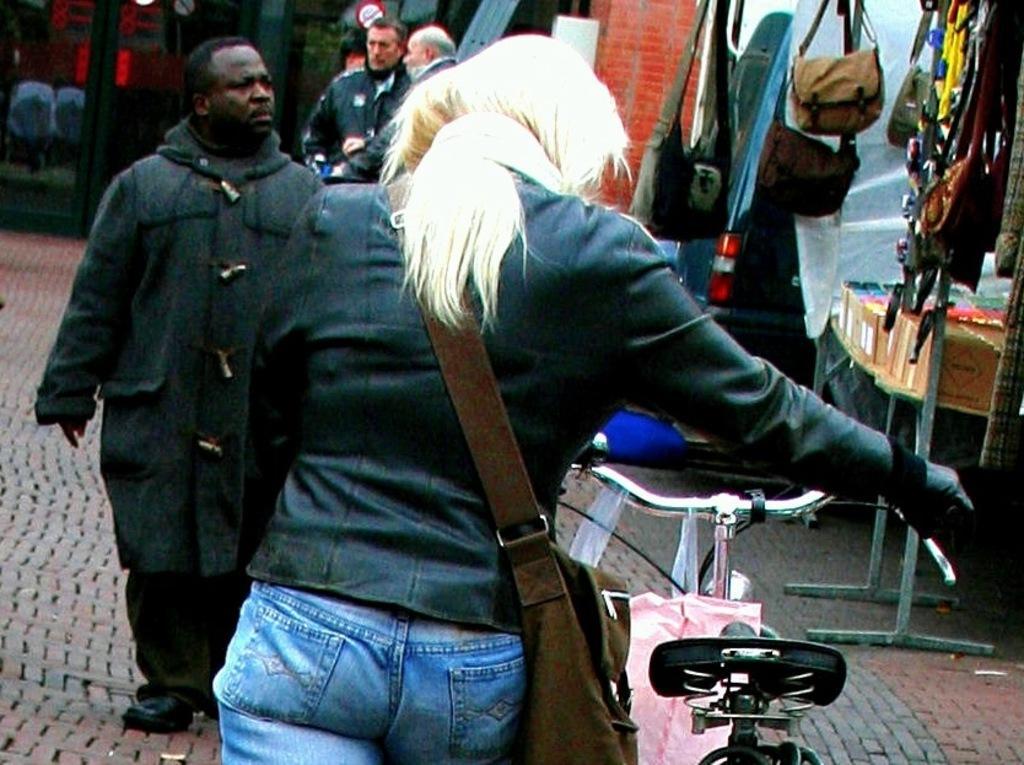How would you summarize this image in a sentence or two? This picture shows a woman holding a bicycle and she wore a bag and walking and we see a man walking and we see stores on the side and we see couple of men standing and we see bags and few ornaments for the sale. 